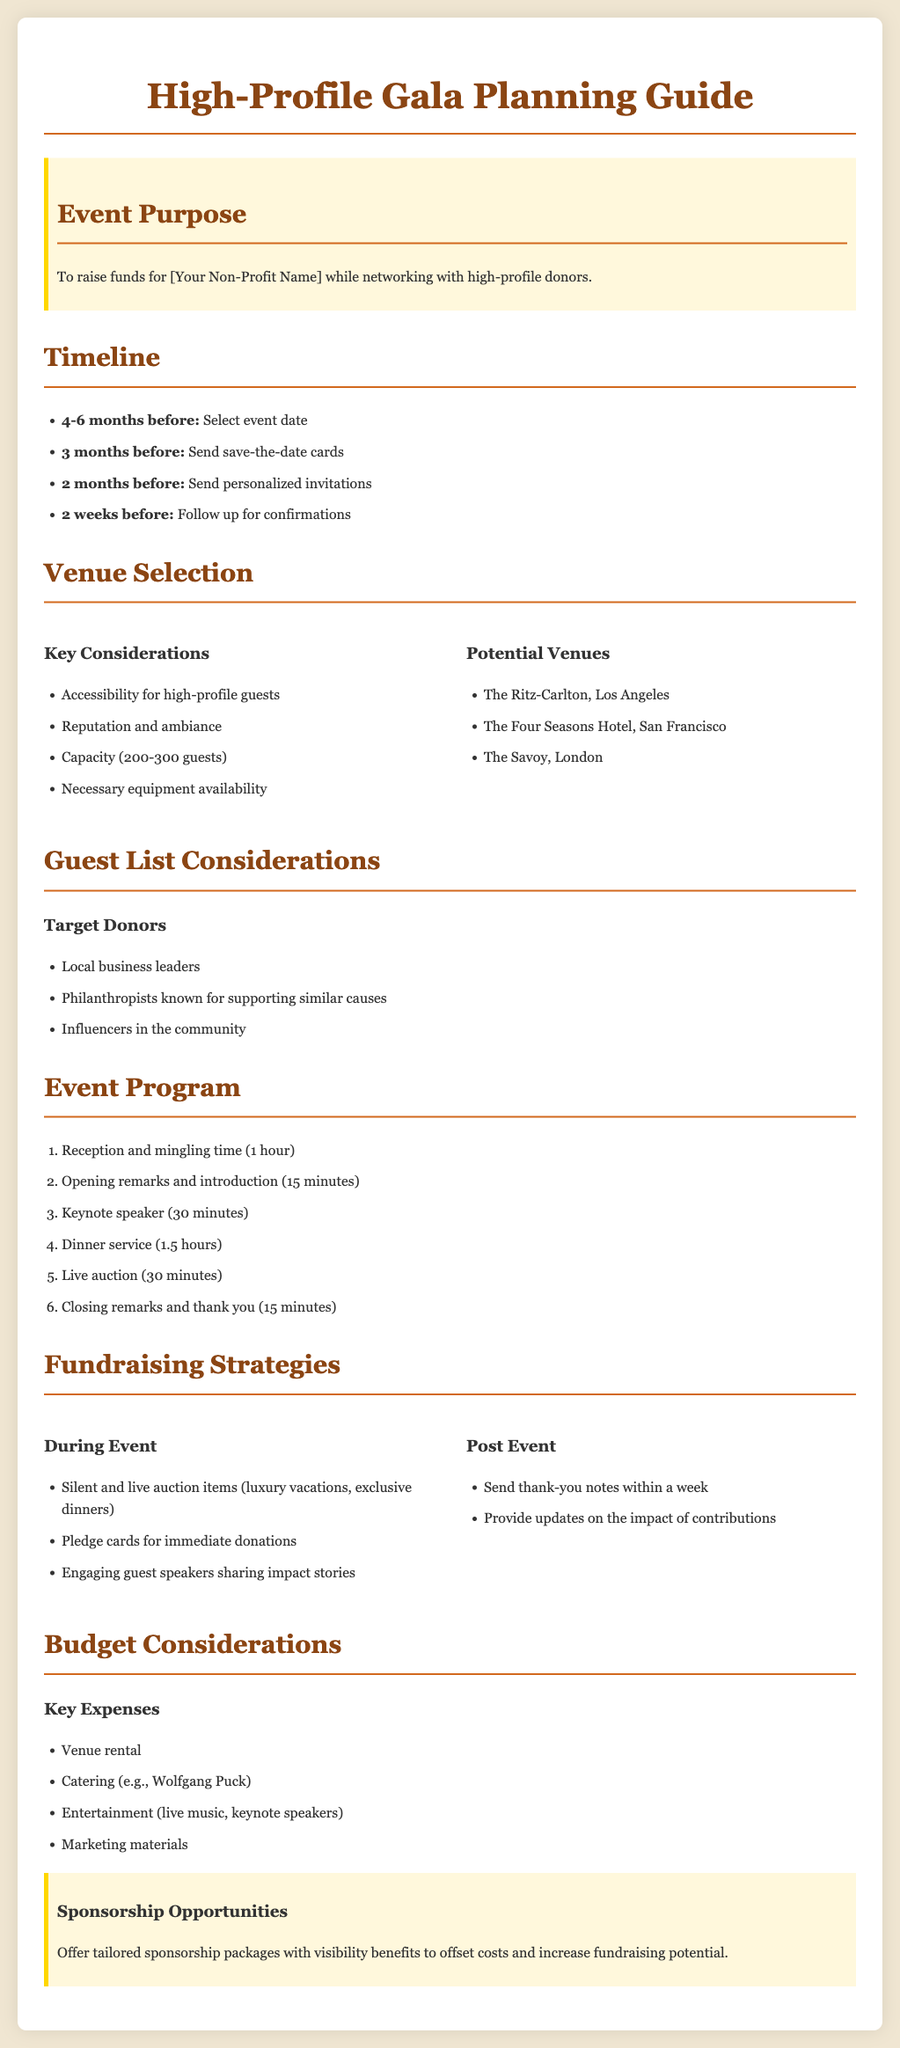What is the event purpose? The purpose is to raise funds for [Your Non-Profit Name] while networking with high-profile donors.
Answer: raise funds for [Your Non-Profit Name] How many months before the event should save-the-date cards be sent? The document states that save-the-date cards should be sent 3 months before the event.
Answer: 3 months What is a key consideration for venue selection? The document lists "Accessibility for high-profile guests" as one of the key considerations for venue selection.
Answer: Accessibility for high-profile guests How long is the reception and mingling time in the event program? The program specifies a reception and mingling time of 1 hour.
Answer: 1 hour What is one fundraising strategy during the event? The document mentions "Silent and live auction items" as one of the fundraising strategies during the event.
Answer: Silent and live auction items How many guests should the venue ideally accommodate? The document indicates that venues should have a capacity of 200-300 guests.
Answer: 200-300 guests What types of individuals are target donors listed in the document? Target donors include local business leaders, philanthropists, and influencers in the community.
Answer: local business leaders, philanthropists, influencers in the community What is a key expense for the gala? The document identifies "Venue rental" as a key expense for the gala.
Answer: Venue rental What two strategies should be implemented post event? The document suggests sending thank-you notes and providing updates on the impact of contributions as strategies post event.
Answer: Send thank-you notes, provide updates on the impact of contributions 